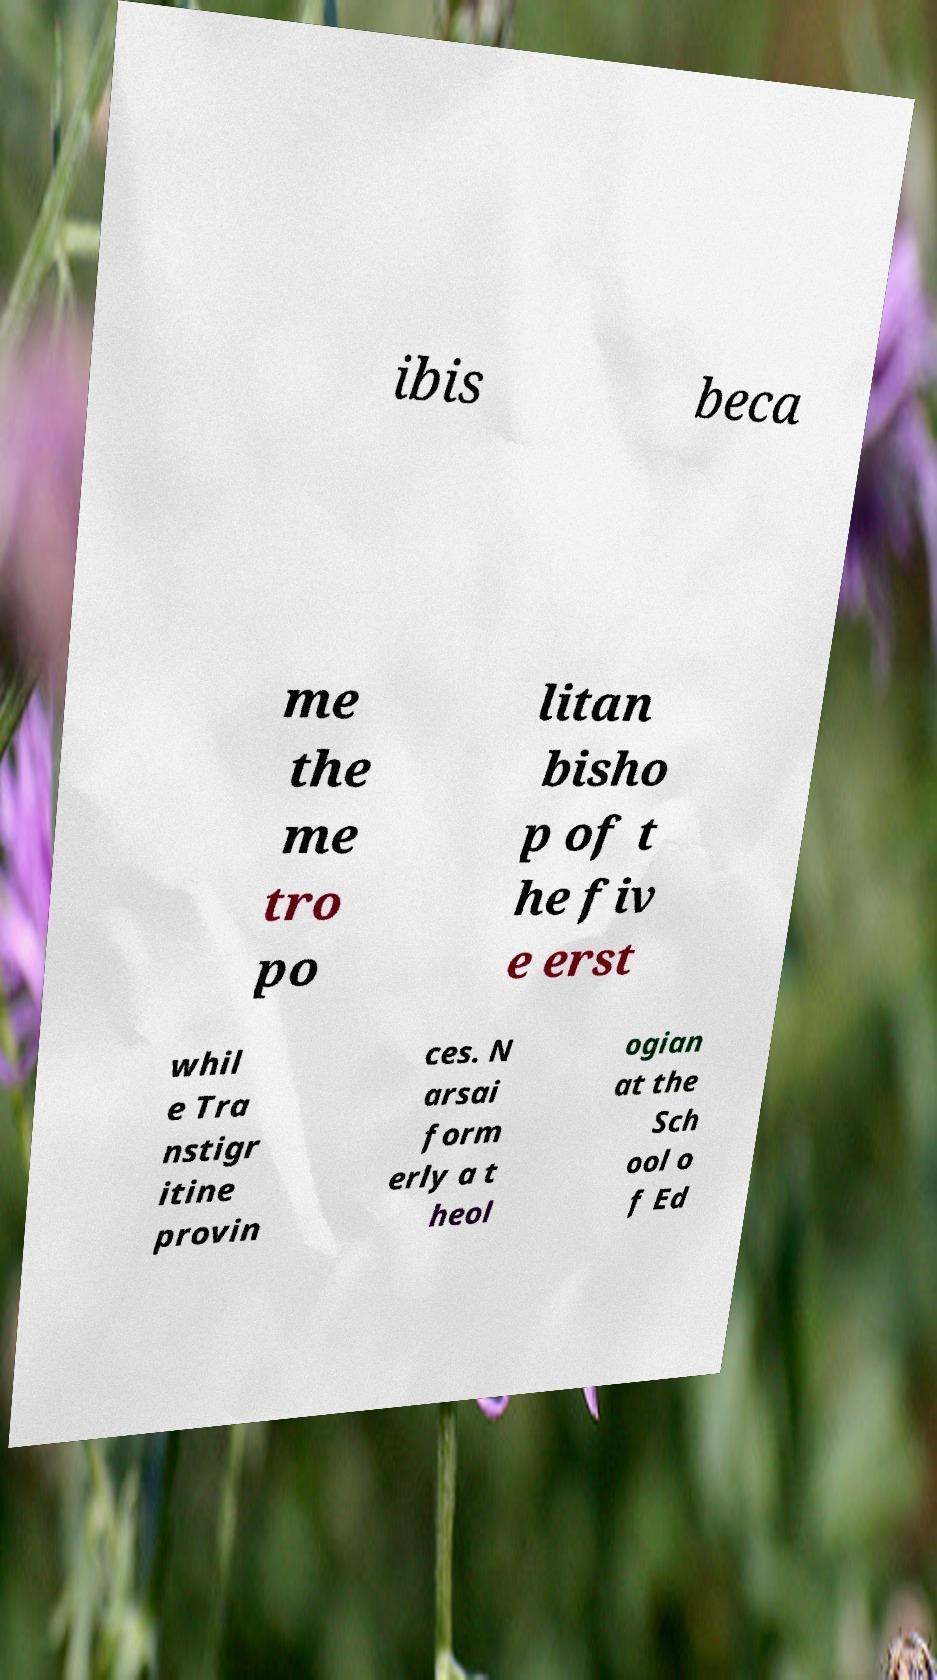Can you accurately transcribe the text from the provided image for me? ibis beca me the me tro po litan bisho p of t he fiv e erst whil e Tra nstigr itine provin ces. N arsai form erly a t heol ogian at the Sch ool o f Ed 